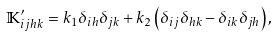<formula> <loc_0><loc_0><loc_500><loc_500>\mathbb { K } _ { i j h k } ^ { \prime } = k _ { 1 } \delta _ { i h } \delta _ { j k } + k _ { 2 } \left ( \delta _ { i j } \delta _ { h k } - \delta _ { i k } \delta _ { j h } \right ) ,</formula> 